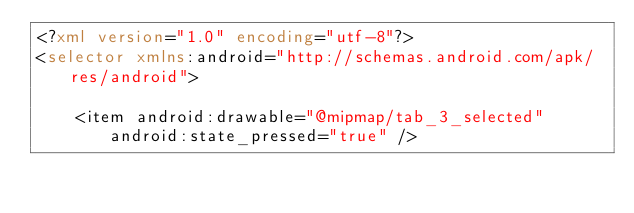<code> <loc_0><loc_0><loc_500><loc_500><_XML_><?xml version="1.0" encoding="utf-8"?>
<selector xmlns:android="http://schemas.android.com/apk/res/android">

    <item android:drawable="@mipmap/tab_3_selected" android:state_pressed="true" /></code> 